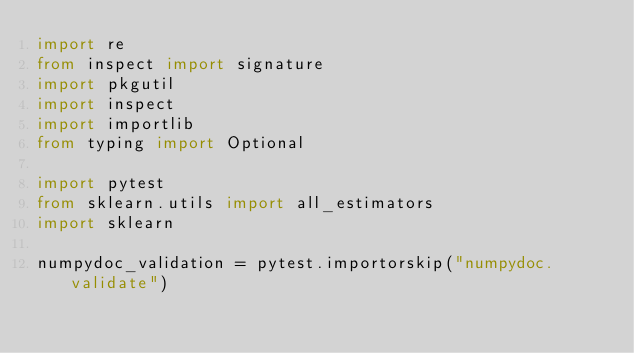Convert code to text. <code><loc_0><loc_0><loc_500><loc_500><_Python_>import re
from inspect import signature
import pkgutil
import inspect
import importlib
from typing import Optional

import pytest
from sklearn.utils import all_estimators
import sklearn

numpydoc_validation = pytest.importorskip("numpydoc.validate")
</code> 